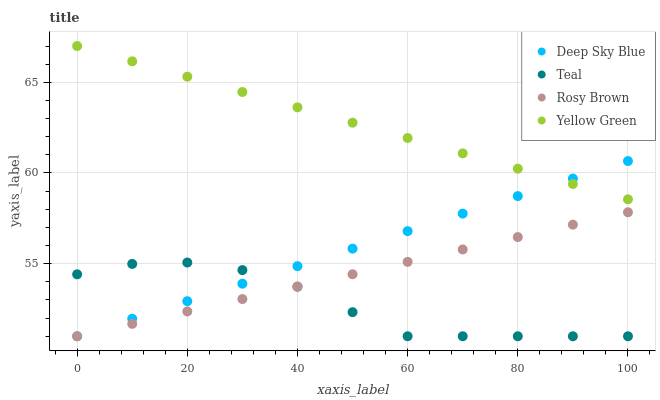Does Teal have the minimum area under the curve?
Answer yes or no. Yes. Does Yellow Green have the maximum area under the curve?
Answer yes or no. Yes. Does Deep Sky Blue have the minimum area under the curve?
Answer yes or no. No. Does Deep Sky Blue have the maximum area under the curve?
Answer yes or no. No. Is Deep Sky Blue the smoothest?
Answer yes or no. Yes. Is Teal the roughest?
Answer yes or no. Yes. Is Teal the smoothest?
Answer yes or no. No. Is Deep Sky Blue the roughest?
Answer yes or no. No. Does Rosy Brown have the lowest value?
Answer yes or no. Yes. Does Yellow Green have the lowest value?
Answer yes or no. No. Does Yellow Green have the highest value?
Answer yes or no. Yes. Does Deep Sky Blue have the highest value?
Answer yes or no. No. Is Rosy Brown less than Yellow Green?
Answer yes or no. Yes. Is Yellow Green greater than Rosy Brown?
Answer yes or no. Yes. Does Teal intersect Deep Sky Blue?
Answer yes or no. Yes. Is Teal less than Deep Sky Blue?
Answer yes or no. No. Is Teal greater than Deep Sky Blue?
Answer yes or no. No. Does Rosy Brown intersect Yellow Green?
Answer yes or no. No. 